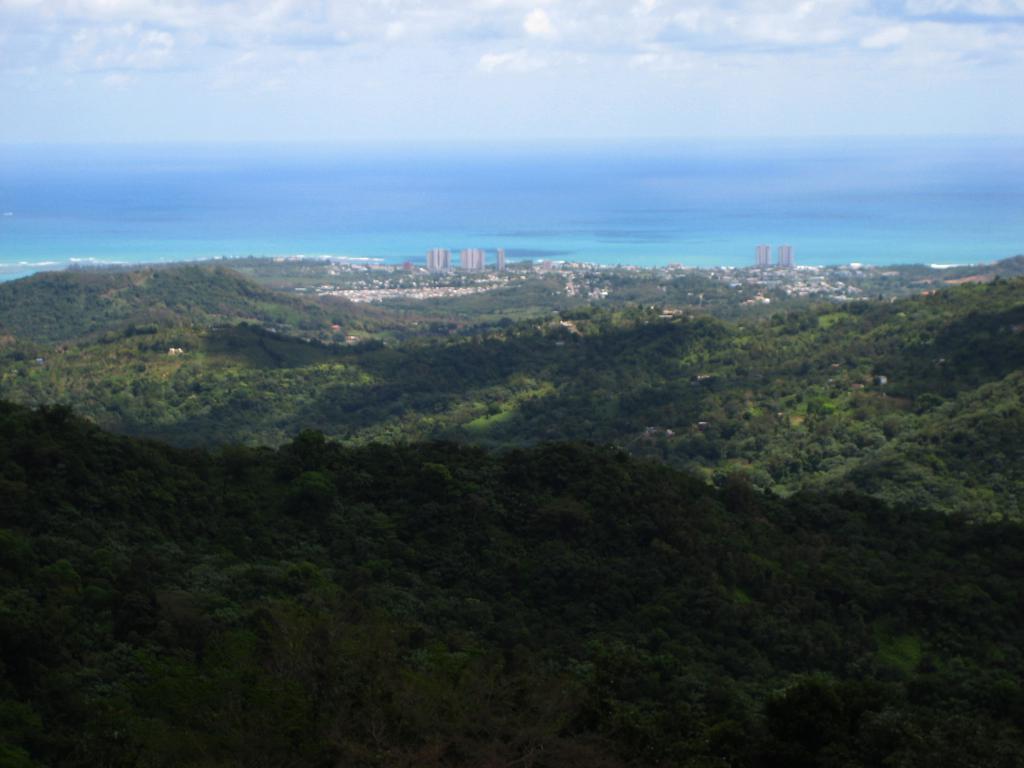In one or two sentences, can you explain what this image depicts? In the foreground of this image, we can see mountains, trees, city, an ocean, and the sky. 